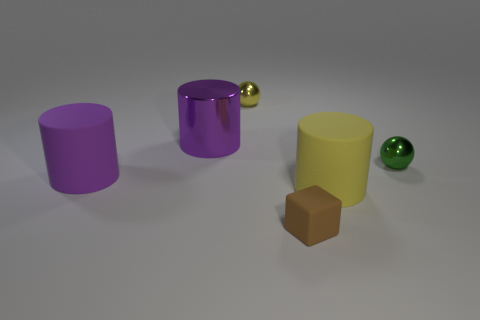Subtract all large purple cylinders. How many cylinders are left? 1 Subtract all yellow cylinders. How many cylinders are left? 2 Subtract all spheres. How many objects are left? 4 Add 4 green rubber objects. How many objects exist? 10 Subtract all gray balls. How many purple cylinders are left? 2 Subtract 1 yellow cylinders. How many objects are left? 5 Subtract all cyan blocks. Subtract all green cylinders. How many blocks are left? 1 Subtract all yellow shiny balls. Subtract all large purple matte cylinders. How many objects are left? 4 Add 5 metal cylinders. How many metal cylinders are left? 6 Add 3 metal objects. How many metal objects exist? 6 